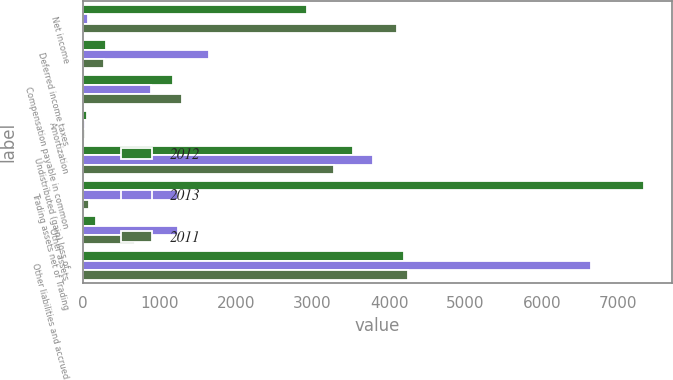<chart> <loc_0><loc_0><loc_500><loc_500><stacked_bar_chart><ecel><fcel>Net income<fcel>Deferred income taxes<fcel>Compensation payable in common<fcel>Amortization<fcel>Undistributed (gain) loss of<fcel>Trading assets net of Trading<fcel>Other assets<fcel>Other liabilities and accrued<nl><fcel>2012<fcel>2932<fcel>303<fcel>1180<fcel>47<fcel>3528<fcel>7332<fcel>165<fcel>4192<nl><fcel>2013<fcel>68<fcel>1653<fcel>891<fcel>23<fcel>3785<fcel>1235<fcel>1235<fcel>6637<nl><fcel>2011<fcel>4110<fcel>279<fcel>1300<fcel>22<fcel>3280<fcel>81<fcel>681<fcel>4242<nl></chart> 